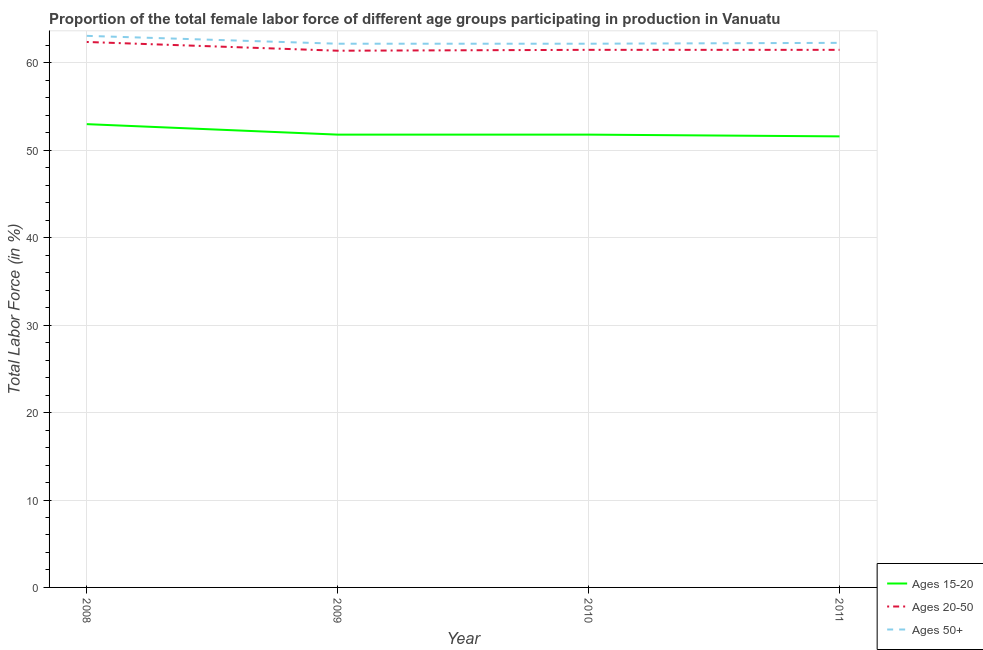How many different coloured lines are there?
Ensure brevity in your answer.  3. Does the line corresponding to percentage of female labor force above age 50 intersect with the line corresponding to percentage of female labor force within the age group 20-50?
Give a very brief answer. No. Is the number of lines equal to the number of legend labels?
Ensure brevity in your answer.  Yes. What is the percentage of female labor force within the age group 15-20 in 2011?
Your answer should be compact. 51.6. Across all years, what is the maximum percentage of female labor force within the age group 15-20?
Keep it short and to the point. 53. Across all years, what is the minimum percentage of female labor force within the age group 20-50?
Keep it short and to the point. 61.4. In which year was the percentage of female labor force within the age group 15-20 maximum?
Offer a very short reply. 2008. In which year was the percentage of female labor force within the age group 15-20 minimum?
Your answer should be very brief. 2011. What is the total percentage of female labor force within the age group 20-50 in the graph?
Provide a short and direct response. 246.8. What is the difference between the percentage of female labor force within the age group 15-20 in 2009 and that in 2011?
Your answer should be compact. 0.2. What is the difference between the percentage of female labor force above age 50 in 2008 and the percentage of female labor force within the age group 15-20 in 2011?
Your response must be concise. 11.5. What is the average percentage of female labor force within the age group 20-50 per year?
Offer a very short reply. 61.7. In the year 2008, what is the difference between the percentage of female labor force within the age group 15-20 and percentage of female labor force above age 50?
Your response must be concise. -10.1. What is the ratio of the percentage of female labor force above age 50 in 2008 to that in 2011?
Your response must be concise. 1.01. Is the percentage of female labor force within the age group 20-50 in 2009 less than that in 2011?
Offer a terse response. Yes. What is the difference between the highest and the second highest percentage of female labor force above age 50?
Provide a succinct answer. 0.8. What is the difference between the highest and the lowest percentage of female labor force above age 50?
Offer a terse response. 0.9. Is the sum of the percentage of female labor force within the age group 15-20 in 2009 and 2010 greater than the maximum percentage of female labor force within the age group 20-50 across all years?
Ensure brevity in your answer.  Yes. How many lines are there?
Ensure brevity in your answer.  3. Does the graph contain grids?
Ensure brevity in your answer.  Yes. Where does the legend appear in the graph?
Provide a short and direct response. Bottom right. How many legend labels are there?
Your answer should be very brief. 3. How are the legend labels stacked?
Keep it short and to the point. Vertical. What is the title of the graph?
Your response must be concise. Proportion of the total female labor force of different age groups participating in production in Vanuatu. What is the label or title of the X-axis?
Provide a short and direct response. Year. What is the label or title of the Y-axis?
Provide a succinct answer. Total Labor Force (in %). What is the Total Labor Force (in %) in Ages 15-20 in 2008?
Your answer should be compact. 53. What is the Total Labor Force (in %) of Ages 20-50 in 2008?
Your answer should be compact. 62.4. What is the Total Labor Force (in %) in Ages 50+ in 2008?
Ensure brevity in your answer.  63.1. What is the Total Labor Force (in %) of Ages 15-20 in 2009?
Offer a very short reply. 51.8. What is the Total Labor Force (in %) in Ages 20-50 in 2009?
Your answer should be very brief. 61.4. What is the Total Labor Force (in %) in Ages 50+ in 2009?
Make the answer very short. 62.2. What is the Total Labor Force (in %) of Ages 15-20 in 2010?
Offer a terse response. 51.8. What is the Total Labor Force (in %) in Ages 20-50 in 2010?
Provide a succinct answer. 61.5. What is the Total Labor Force (in %) in Ages 50+ in 2010?
Make the answer very short. 62.2. What is the Total Labor Force (in %) of Ages 15-20 in 2011?
Provide a short and direct response. 51.6. What is the Total Labor Force (in %) in Ages 20-50 in 2011?
Give a very brief answer. 61.5. What is the Total Labor Force (in %) in Ages 50+ in 2011?
Provide a succinct answer. 62.3. Across all years, what is the maximum Total Labor Force (in %) of Ages 20-50?
Provide a succinct answer. 62.4. Across all years, what is the maximum Total Labor Force (in %) of Ages 50+?
Offer a very short reply. 63.1. Across all years, what is the minimum Total Labor Force (in %) in Ages 15-20?
Your answer should be very brief. 51.6. Across all years, what is the minimum Total Labor Force (in %) of Ages 20-50?
Offer a terse response. 61.4. Across all years, what is the minimum Total Labor Force (in %) in Ages 50+?
Offer a terse response. 62.2. What is the total Total Labor Force (in %) in Ages 15-20 in the graph?
Offer a terse response. 208.2. What is the total Total Labor Force (in %) in Ages 20-50 in the graph?
Your answer should be compact. 246.8. What is the total Total Labor Force (in %) in Ages 50+ in the graph?
Keep it short and to the point. 249.8. What is the difference between the Total Labor Force (in %) in Ages 15-20 in 2008 and that in 2009?
Give a very brief answer. 1.2. What is the difference between the Total Labor Force (in %) in Ages 20-50 in 2008 and that in 2009?
Offer a very short reply. 1. What is the difference between the Total Labor Force (in %) in Ages 15-20 in 2008 and that in 2011?
Your response must be concise. 1.4. What is the difference between the Total Labor Force (in %) in Ages 50+ in 2008 and that in 2011?
Ensure brevity in your answer.  0.8. What is the difference between the Total Labor Force (in %) in Ages 50+ in 2009 and that in 2010?
Provide a short and direct response. 0. What is the difference between the Total Labor Force (in %) in Ages 50+ in 2009 and that in 2011?
Make the answer very short. -0.1. What is the difference between the Total Labor Force (in %) of Ages 20-50 in 2010 and that in 2011?
Offer a terse response. 0. What is the difference between the Total Labor Force (in %) in Ages 50+ in 2010 and that in 2011?
Give a very brief answer. -0.1. What is the difference between the Total Labor Force (in %) of Ages 15-20 in 2008 and the Total Labor Force (in %) of Ages 50+ in 2009?
Ensure brevity in your answer.  -9.2. What is the difference between the Total Labor Force (in %) in Ages 20-50 in 2008 and the Total Labor Force (in %) in Ages 50+ in 2009?
Your answer should be compact. 0.2. What is the difference between the Total Labor Force (in %) of Ages 15-20 in 2008 and the Total Labor Force (in %) of Ages 20-50 in 2010?
Keep it short and to the point. -8.5. What is the difference between the Total Labor Force (in %) in Ages 15-20 in 2008 and the Total Labor Force (in %) in Ages 50+ in 2010?
Offer a terse response. -9.2. What is the difference between the Total Labor Force (in %) of Ages 15-20 in 2008 and the Total Labor Force (in %) of Ages 50+ in 2011?
Make the answer very short. -9.3. What is the difference between the Total Labor Force (in %) in Ages 20-50 in 2008 and the Total Labor Force (in %) in Ages 50+ in 2011?
Give a very brief answer. 0.1. What is the difference between the Total Labor Force (in %) in Ages 15-20 in 2009 and the Total Labor Force (in %) in Ages 20-50 in 2011?
Offer a terse response. -9.7. What is the difference between the Total Labor Force (in %) in Ages 15-20 in 2009 and the Total Labor Force (in %) in Ages 50+ in 2011?
Provide a succinct answer. -10.5. What is the difference between the Total Labor Force (in %) in Ages 15-20 in 2010 and the Total Labor Force (in %) in Ages 20-50 in 2011?
Offer a terse response. -9.7. What is the difference between the Total Labor Force (in %) of Ages 15-20 in 2010 and the Total Labor Force (in %) of Ages 50+ in 2011?
Offer a terse response. -10.5. What is the average Total Labor Force (in %) of Ages 15-20 per year?
Offer a terse response. 52.05. What is the average Total Labor Force (in %) of Ages 20-50 per year?
Your response must be concise. 61.7. What is the average Total Labor Force (in %) of Ages 50+ per year?
Offer a terse response. 62.45. In the year 2008, what is the difference between the Total Labor Force (in %) in Ages 15-20 and Total Labor Force (in %) in Ages 50+?
Keep it short and to the point. -10.1. In the year 2009, what is the difference between the Total Labor Force (in %) of Ages 15-20 and Total Labor Force (in %) of Ages 20-50?
Offer a very short reply. -9.6. In the year 2009, what is the difference between the Total Labor Force (in %) in Ages 15-20 and Total Labor Force (in %) in Ages 50+?
Provide a succinct answer. -10.4. In the year 2010, what is the difference between the Total Labor Force (in %) in Ages 20-50 and Total Labor Force (in %) in Ages 50+?
Your answer should be very brief. -0.7. In the year 2011, what is the difference between the Total Labor Force (in %) in Ages 15-20 and Total Labor Force (in %) in Ages 50+?
Your response must be concise. -10.7. What is the ratio of the Total Labor Force (in %) in Ages 15-20 in 2008 to that in 2009?
Your response must be concise. 1.02. What is the ratio of the Total Labor Force (in %) of Ages 20-50 in 2008 to that in 2009?
Offer a terse response. 1.02. What is the ratio of the Total Labor Force (in %) of Ages 50+ in 2008 to that in 2009?
Your response must be concise. 1.01. What is the ratio of the Total Labor Force (in %) of Ages 15-20 in 2008 to that in 2010?
Offer a very short reply. 1.02. What is the ratio of the Total Labor Force (in %) in Ages 20-50 in 2008 to that in 2010?
Keep it short and to the point. 1.01. What is the ratio of the Total Labor Force (in %) in Ages 50+ in 2008 to that in 2010?
Offer a very short reply. 1.01. What is the ratio of the Total Labor Force (in %) in Ages 15-20 in 2008 to that in 2011?
Offer a very short reply. 1.03. What is the ratio of the Total Labor Force (in %) of Ages 20-50 in 2008 to that in 2011?
Offer a very short reply. 1.01. What is the ratio of the Total Labor Force (in %) of Ages 50+ in 2008 to that in 2011?
Your answer should be very brief. 1.01. What is the ratio of the Total Labor Force (in %) of Ages 20-50 in 2009 to that in 2010?
Provide a short and direct response. 1. What is the ratio of the Total Labor Force (in %) in Ages 50+ in 2009 to that in 2010?
Your response must be concise. 1. What is the ratio of the Total Labor Force (in %) in Ages 50+ in 2009 to that in 2011?
Ensure brevity in your answer.  1. What is the ratio of the Total Labor Force (in %) of Ages 50+ in 2010 to that in 2011?
Provide a succinct answer. 1. What is the difference between the highest and the second highest Total Labor Force (in %) of Ages 20-50?
Provide a succinct answer. 0.9. What is the difference between the highest and the lowest Total Labor Force (in %) in Ages 15-20?
Offer a terse response. 1.4. What is the difference between the highest and the lowest Total Labor Force (in %) of Ages 50+?
Your response must be concise. 0.9. 